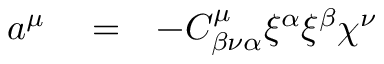<formula> <loc_0><loc_0><loc_500><loc_500>\begin{array} { r l r } { a ^ { \mu } } & = } & { - C _ { \beta \nu \alpha } ^ { \mu } \xi ^ { \alpha } \xi ^ { \beta } \chi ^ { \nu } } \end{array}</formula> 